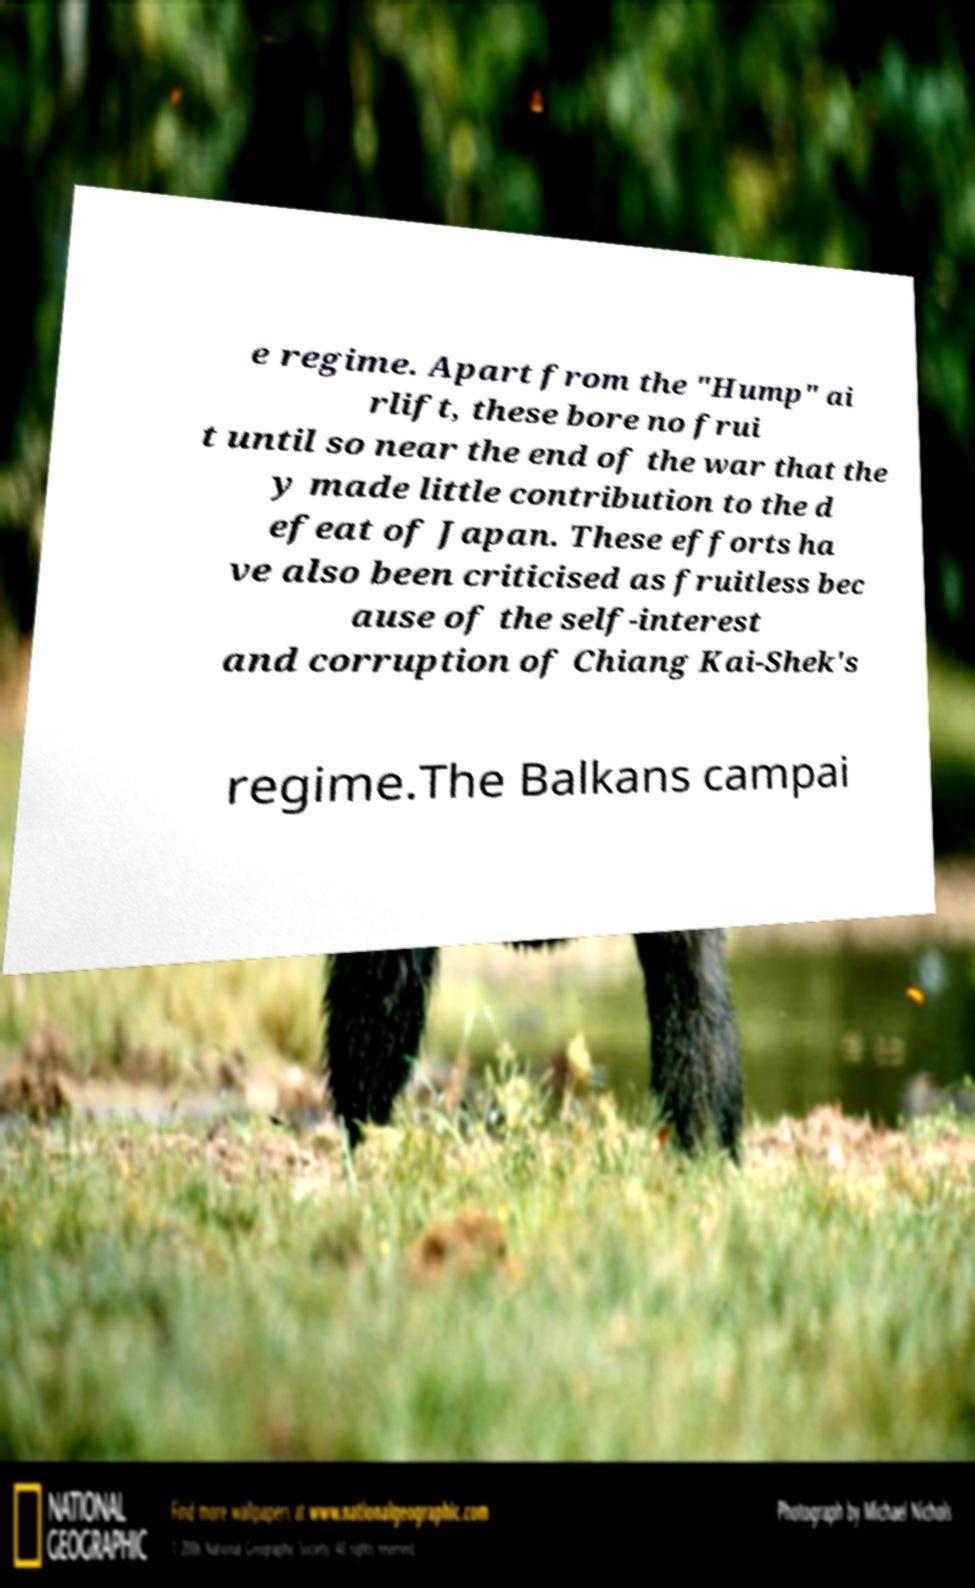Please identify and transcribe the text found in this image. e regime. Apart from the "Hump" ai rlift, these bore no frui t until so near the end of the war that the y made little contribution to the d efeat of Japan. These efforts ha ve also been criticised as fruitless bec ause of the self-interest and corruption of Chiang Kai-Shek's regime.The Balkans campai 